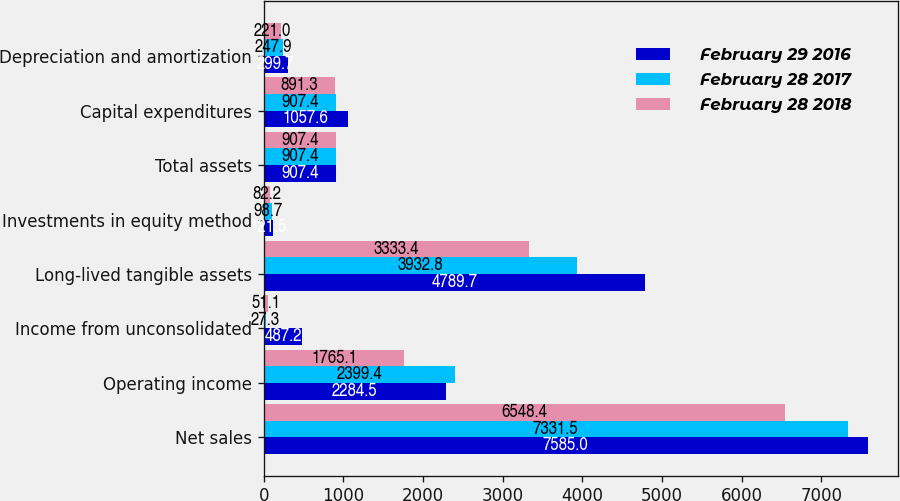Convert chart. <chart><loc_0><loc_0><loc_500><loc_500><stacked_bar_chart><ecel><fcel>Net sales<fcel>Operating income<fcel>Income from unconsolidated<fcel>Long-lived tangible assets<fcel>Investments in equity method<fcel>Total assets<fcel>Capital expenditures<fcel>Depreciation and amortization<nl><fcel>February 29 2016<fcel>7585<fcel>2284.5<fcel>487.2<fcel>4789.7<fcel>121.5<fcel>907.4<fcel>1057.6<fcel>299.7<nl><fcel>February 28 2017<fcel>7331.5<fcel>2399.4<fcel>27.3<fcel>3932.8<fcel>98.7<fcel>907.4<fcel>907.4<fcel>247.9<nl><fcel>February 28 2018<fcel>6548.4<fcel>1765.1<fcel>51.1<fcel>3333.4<fcel>82.2<fcel>907.4<fcel>891.3<fcel>221<nl></chart> 